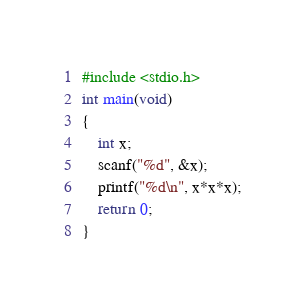<code> <loc_0><loc_0><loc_500><loc_500><_C_>#include <stdio.h>
int main(void)
{
	int x;
	scanf("%d", &x);
	printf("%d\n", x*x*x);
	return 0;
}
</code> 